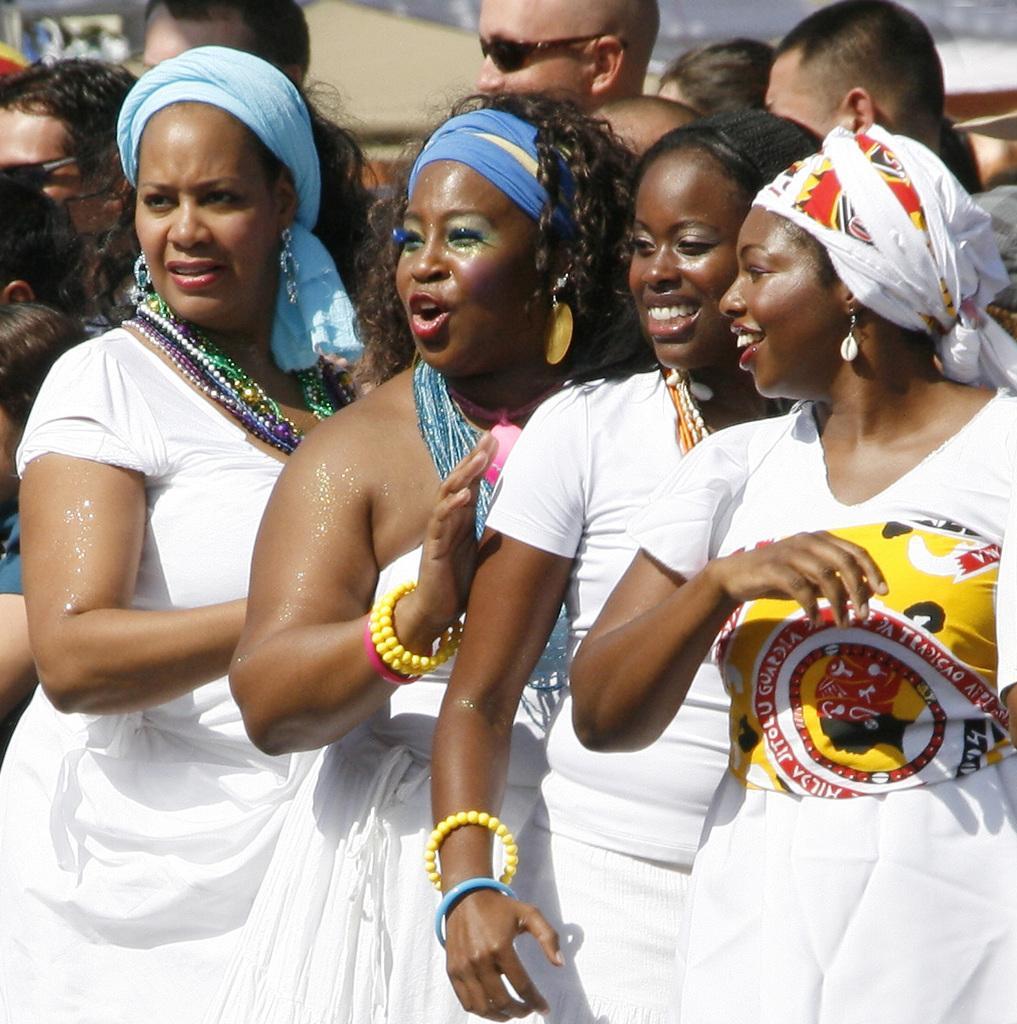Describe this image in one or two sentences. In this image we can see some persons. In the background of the image there are some persons and other objects. 